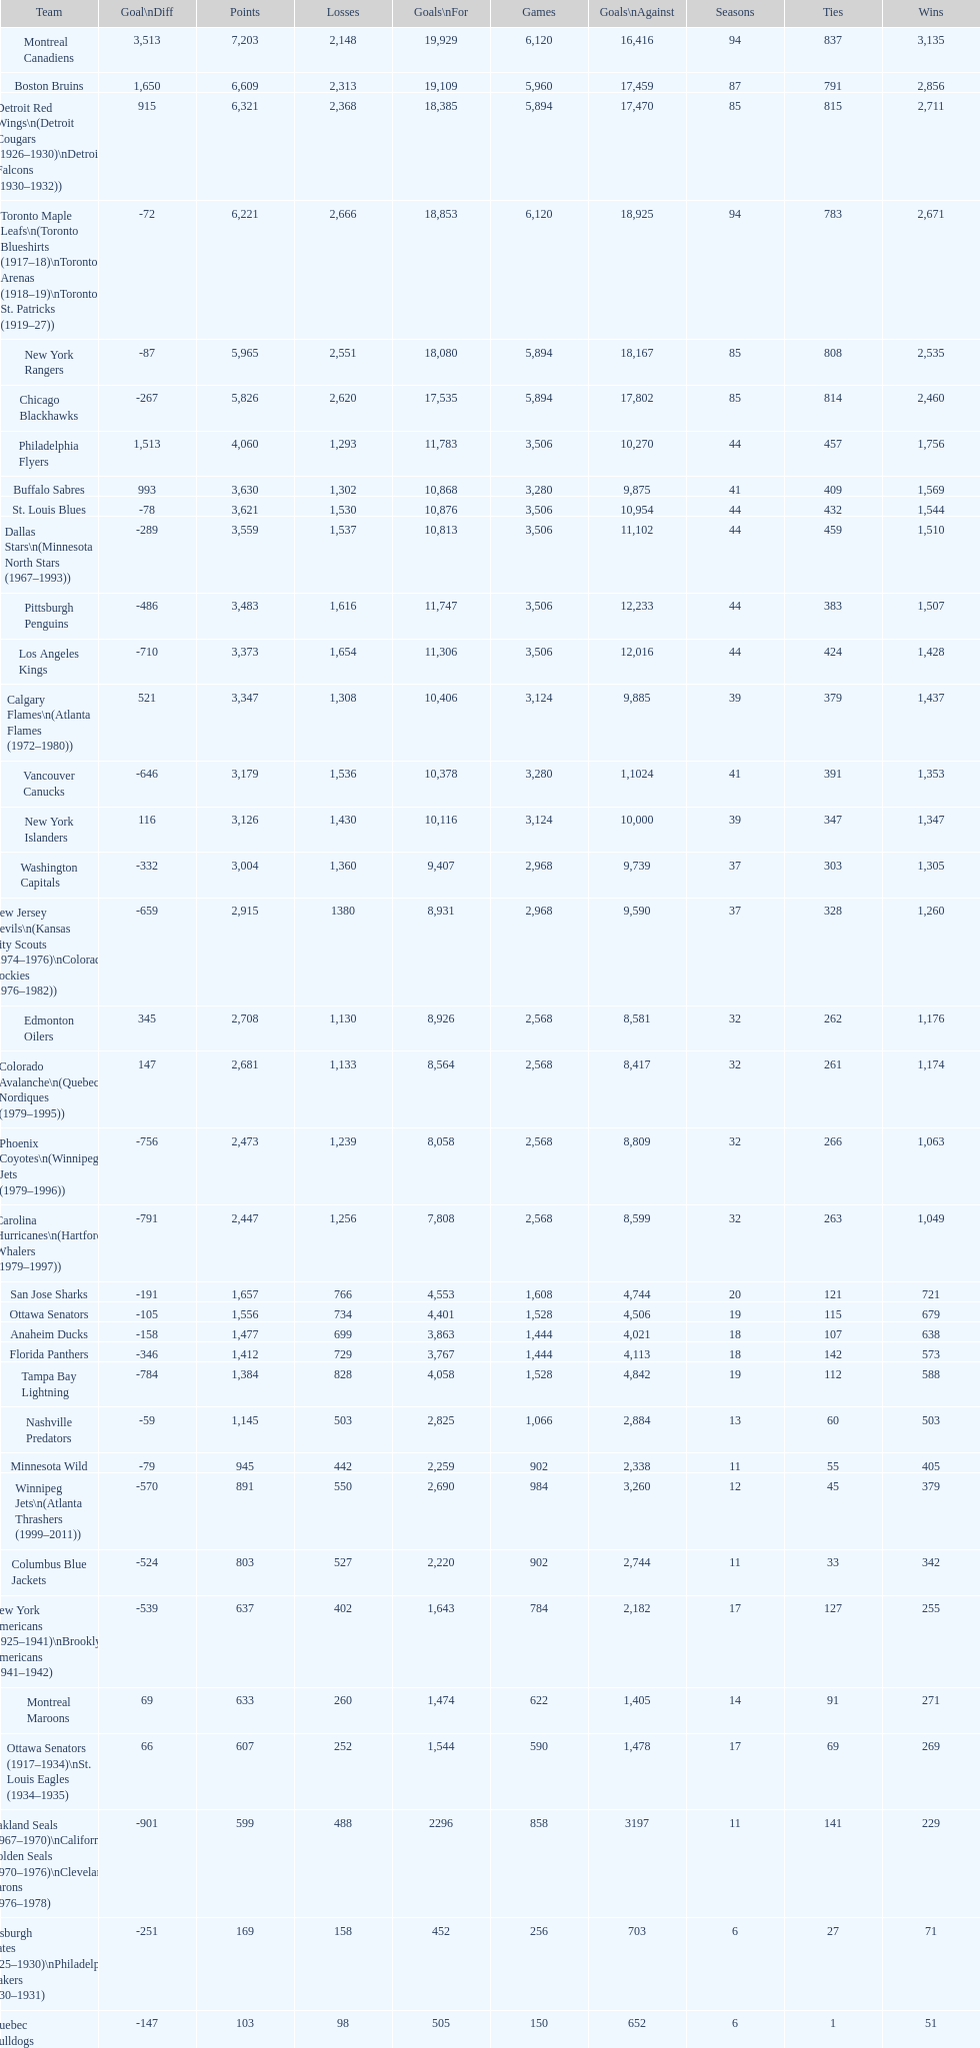Who is at the top of the list? Montreal Canadiens. Would you be able to parse every entry in this table? {'header': ['Team', 'Goal\\nDiff', 'Points', 'Losses', 'Goals\\nFor', 'Games', 'Goals\\nAgainst', 'Seasons', 'Ties', 'Wins'], 'rows': [['Montreal Canadiens', '3,513', '7,203', '2,148', '19,929', '6,120', '16,416', '94', '837', '3,135'], ['Boston Bruins', '1,650', '6,609', '2,313', '19,109', '5,960', '17,459', '87', '791', '2,856'], ['Detroit Red Wings\\n(Detroit Cougars (1926–1930)\\nDetroit Falcons (1930–1932))', '915', '6,321', '2,368', '18,385', '5,894', '17,470', '85', '815', '2,711'], ['Toronto Maple Leafs\\n(Toronto Blueshirts (1917–18)\\nToronto Arenas (1918–19)\\nToronto St. Patricks (1919–27))', '-72', '6,221', '2,666', '18,853', '6,120', '18,925', '94', '783', '2,671'], ['New York Rangers', '-87', '5,965', '2,551', '18,080', '5,894', '18,167', '85', '808', '2,535'], ['Chicago Blackhawks', '-267', '5,826', '2,620', '17,535', '5,894', '17,802', '85', '814', '2,460'], ['Philadelphia Flyers', '1,513', '4,060', '1,293', '11,783', '3,506', '10,270', '44', '457', '1,756'], ['Buffalo Sabres', '993', '3,630', '1,302', '10,868', '3,280', '9,875', '41', '409', '1,569'], ['St. Louis Blues', '-78', '3,621', '1,530', '10,876', '3,506', '10,954', '44', '432', '1,544'], ['Dallas Stars\\n(Minnesota North Stars (1967–1993))', '-289', '3,559', '1,537', '10,813', '3,506', '11,102', '44', '459', '1,510'], ['Pittsburgh Penguins', '-486', '3,483', '1,616', '11,747', '3,506', '12,233', '44', '383', '1,507'], ['Los Angeles Kings', '-710', '3,373', '1,654', '11,306', '3,506', '12,016', '44', '424', '1,428'], ['Calgary Flames\\n(Atlanta Flames (1972–1980))', '521', '3,347', '1,308', '10,406', '3,124', '9,885', '39', '379', '1,437'], ['Vancouver Canucks', '-646', '3,179', '1,536', '10,378', '3,280', '1,1024', '41', '391', '1,353'], ['New York Islanders', '116', '3,126', '1,430', '10,116', '3,124', '10,000', '39', '347', '1,347'], ['Washington Capitals', '-332', '3,004', '1,360', '9,407', '2,968', '9,739', '37', '303', '1,305'], ['New Jersey Devils\\n(Kansas City Scouts (1974–1976)\\nColorado Rockies (1976–1982))', '-659', '2,915', '1380', '8,931', '2,968', '9,590', '37', '328', '1,260'], ['Edmonton Oilers', '345', '2,708', '1,130', '8,926', '2,568', '8,581', '32', '262', '1,176'], ['Colorado Avalanche\\n(Quebec Nordiques (1979–1995))', '147', '2,681', '1,133', '8,564', '2,568', '8,417', '32', '261', '1,174'], ['Phoenix Coyotes\\n(Winnipeg Jets (1979–1996))', '-756', '2,473', '1,239', '8,058', '2,568', '8,809', '32', '266', '1,063'], ['Carolina Hurricanes\\n(Hartford Whalers (1979–1997))', '-791', '2,447', '1,256', '7,808', '2,568', '8,599', '32', '263', '1,049'], ['San Jose Sharks', '-191', '1,657', '766', '4,553', '1,608', '4,744', '20', '121', '721'], ['Ottawa Senators', '-105', '1,556', '734', '4,401', '1,528', '4,506', '19', '115', '679'], ['Anaheim Ducks', '-158', '1,477', '699', '3,863', '1,444', '4,021', '18', '107', '638'], ['Florida Panthers', '-346', '1,412', '729', '3,767', '1,444', '4,113', '18', '142', '573'], ['Tampa Bay Lightning', '-784', '1,384', '828', '4,058', '1,528', '4,842', '19', '112', '588'], ['Nashville Predators', '-59', '1,145', '503', '2,825', '1,066', '2,884', '13', '60', '503'], ['Minnesota Wild', '-79', '945', '442', '2,259', '902', '2,338', '11', '55', '405'], ['Winnipeg Jets\\n(Atlanta Thrashers (1999–2011))', '-570', '891', '550', '2,690', '984', '3,260', '12', '45', '379'], ['Columbus Blue Jackets', '-524', '803', '527', '2,220', '902', '2,744', '11', '33', '342'], ['New York Americans (1925–1941)\\nBrooklyn Americans (1941–1942)', '-539', '637', '402', '1,643', '784', '2,182', '17', '127', '255'], ['Montreal Maroons', '69', '633', '260', '1,474', '622', '1,405', '14', '91', '271'], ['Ottawa Senators (1917–1934)\\nSt. Louis Eagles (1934–1935)', '66', '607', '252', '1,544', '590', '1,478', '17', '69', '269'], ['Oakland Seals (1967–1970)\\nCalifornia Golden Seals (1970–1976)\\nCleveland Barons (1976–1978)', '-901', '599', '488', '2296', '858', '3197', '11', '141', '229'], ['Pittsburgh Pirates (1925–1930)\\nPhiladelphia Quakers (1930–1931)', '-251', '169', '158', '452', '256', '703', '6', '27', '71'], ['Quebec Bulldogs (1919–1920)\\nHamilton Tigers (1920–1925)', '-147', '103', '98', '505', '150', '652', '6', '1', '51'], ['Montreal Wanderers', '-18', '2', '5', '17', '6', '35', '1', '0', '1']]} 